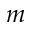<formula> <loc_0><loc_0><loc_500><loc_500>m</formula> 